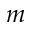<formula> <loc_0><loc_0><loc_500><loc_500>m</formula> 